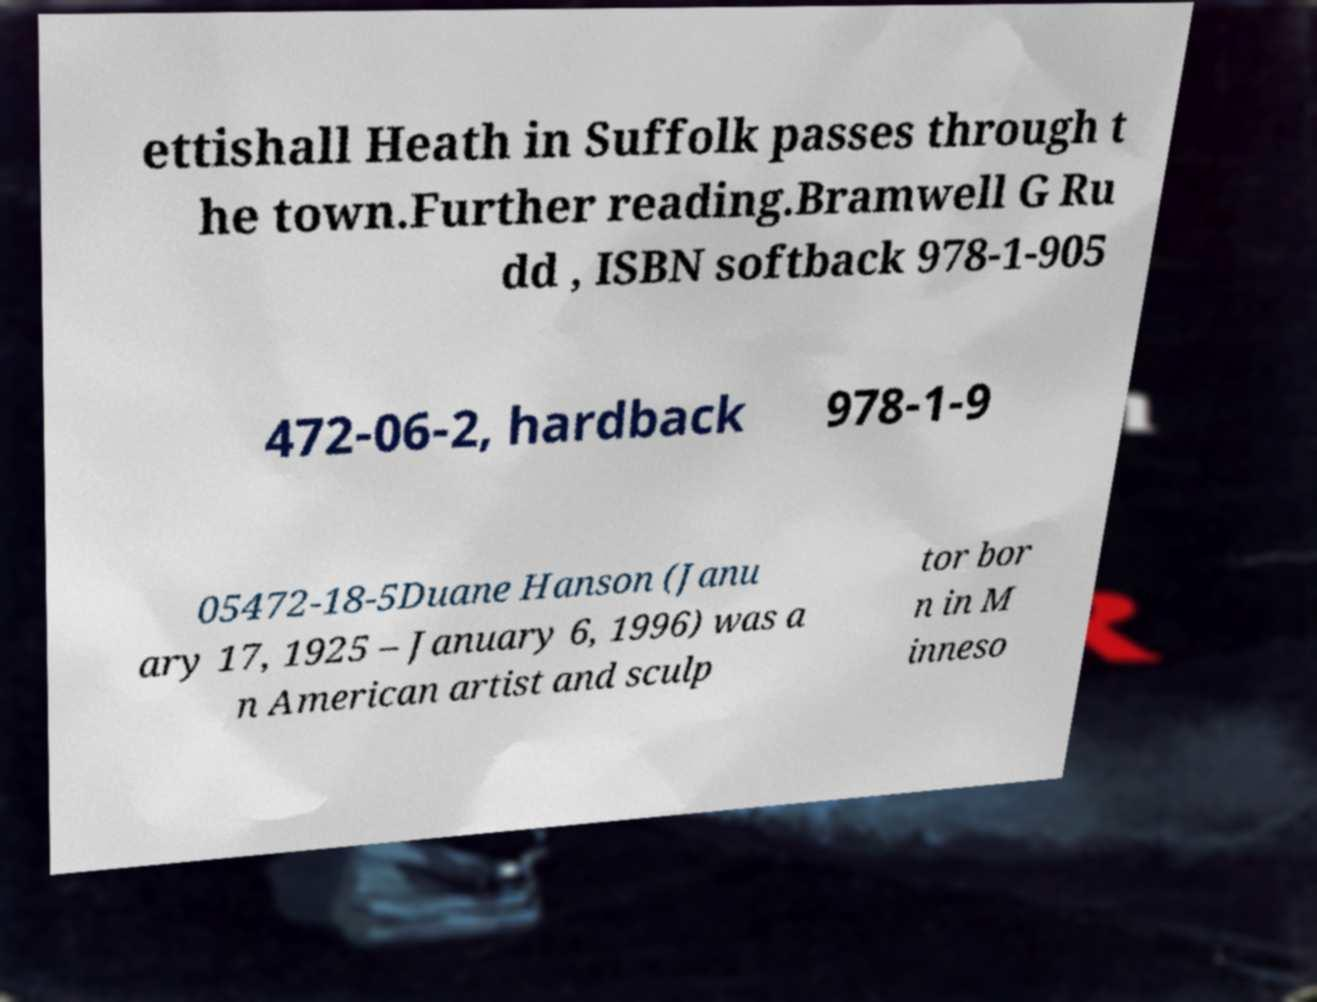Please read and relay the text visible in this image. What does it say? ettishall Heath in Suffolk passes through t he town.Further reading.Bramwell G Ru dd , ISBN softback 978-1-905 472-06-2, hardback 978-1-9 05472-18-5Duane Hanson (Janu ary 17, 1925 – January 6, 1996) was a n American artist and sculp tor bor n in M inneso 